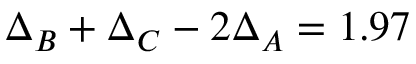<formula> <loc_0><loc_0><loc_500><loc_500>\Delta _ { B } + \Delta _ { C } - 2 \Delta _ { A } = 1 . 9 7</formula> 